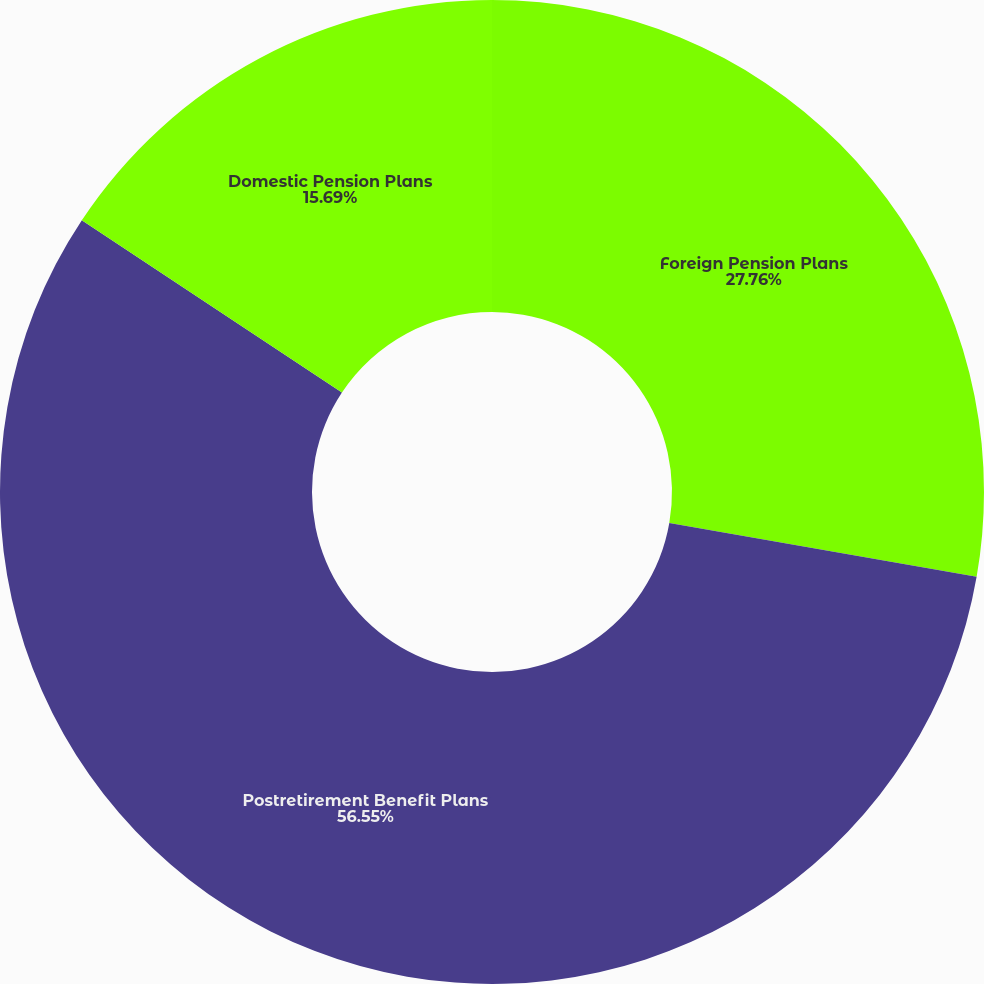Convert chart to OTSL. <chart><loc_0><loc_0><loc_500><loc_500><pie_chart><fcel>Foreign Pension Plans<fcel>Postretirement Benefit Plans<fcel>Domestic Pension Plans<nl><fcel>27.76%<fcel>56.56%<fcel>15.69%<nl></chart> 